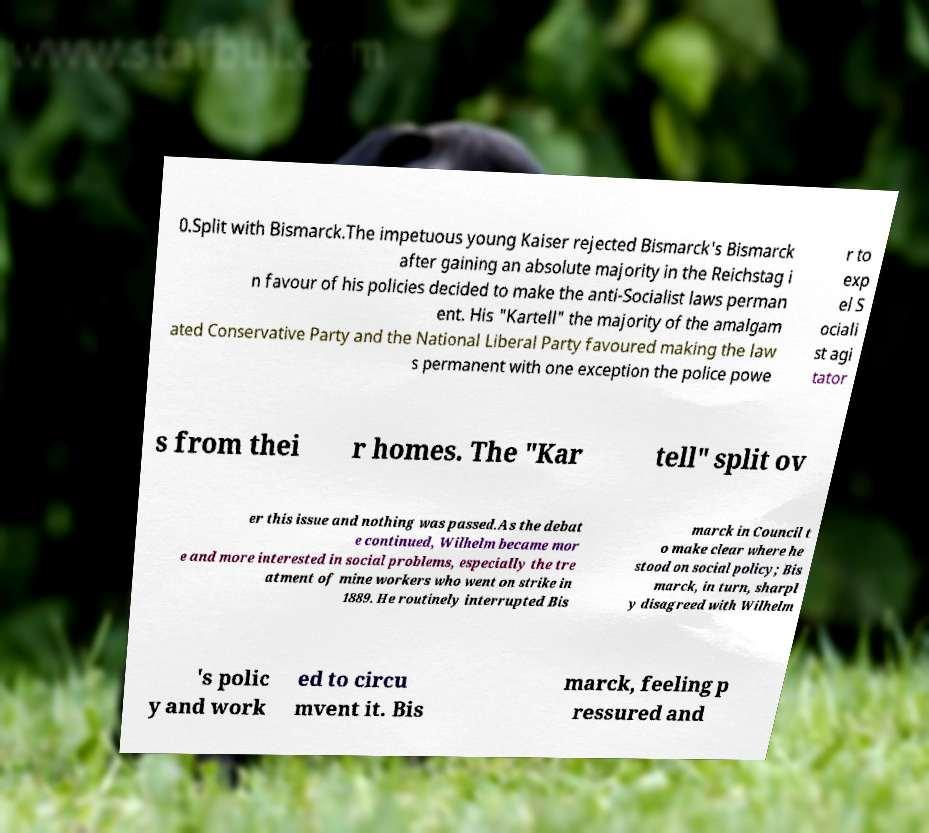I need the written content from this picture converted into text. Can you do that? 0.Split with Bismarck.The impetuous young Kaiser rejected Bismarck's Bismarck after gaining an absolute majority in the Reichstag i n favour of his policies decided to make the anti-Socialist laws perman ent. His "Kartell" the majority of the amalgam ated Conservative Party and the National Liberal Party favoured making the law s permanent with one exception the police powe r to exp el S ociali st agi tator s from thei r homes. The "Kar tell" split ov er this issue and nothing was passed.As the debat e continued, Wilhelm became mor e and more interested in social problems, especially the tre atment of mine workers who went on strike in 1889. He routinely interrupted Bis marck in Council t o make clear where he stood on social policy; Bis marck, in turn, sharpl y disagreed with Wilhelm 's polic y and work ed to circu mvent it. Bis marck, feeling p ressured and 